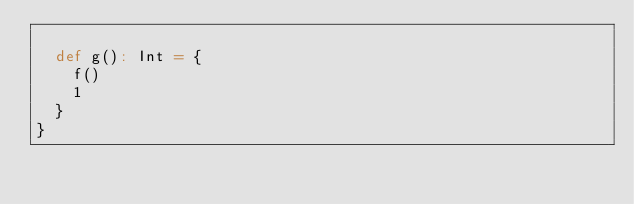Convert code to text. <code><loc_0><loc_0><loc_500><loc_500><_Scala_>
  def g(): Int = {
    f()
    1
  }
}
</code> 